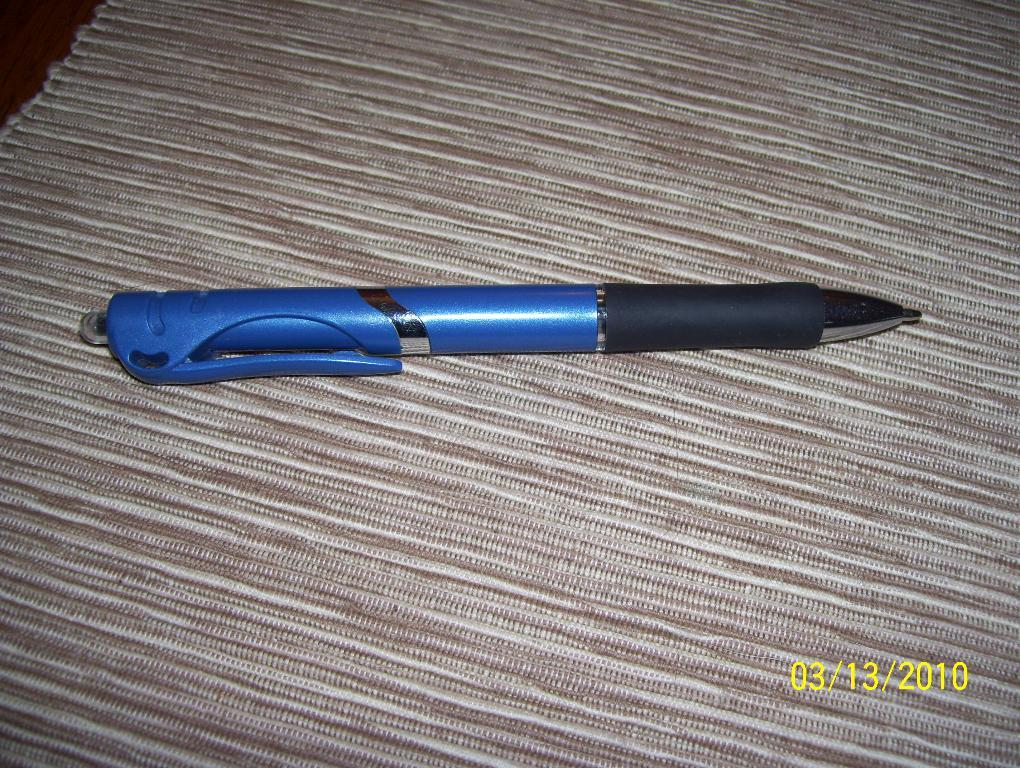What object is present in the image? There is a pen in the image. What is the pen placed on? The pen is on a brown and cream color cloth. What colors can be seen on the pen? The pen has blue and black colors. What type of food is being served on the cart in the image? There is no cart or food present in the image; it only features a pen on a cloth. 